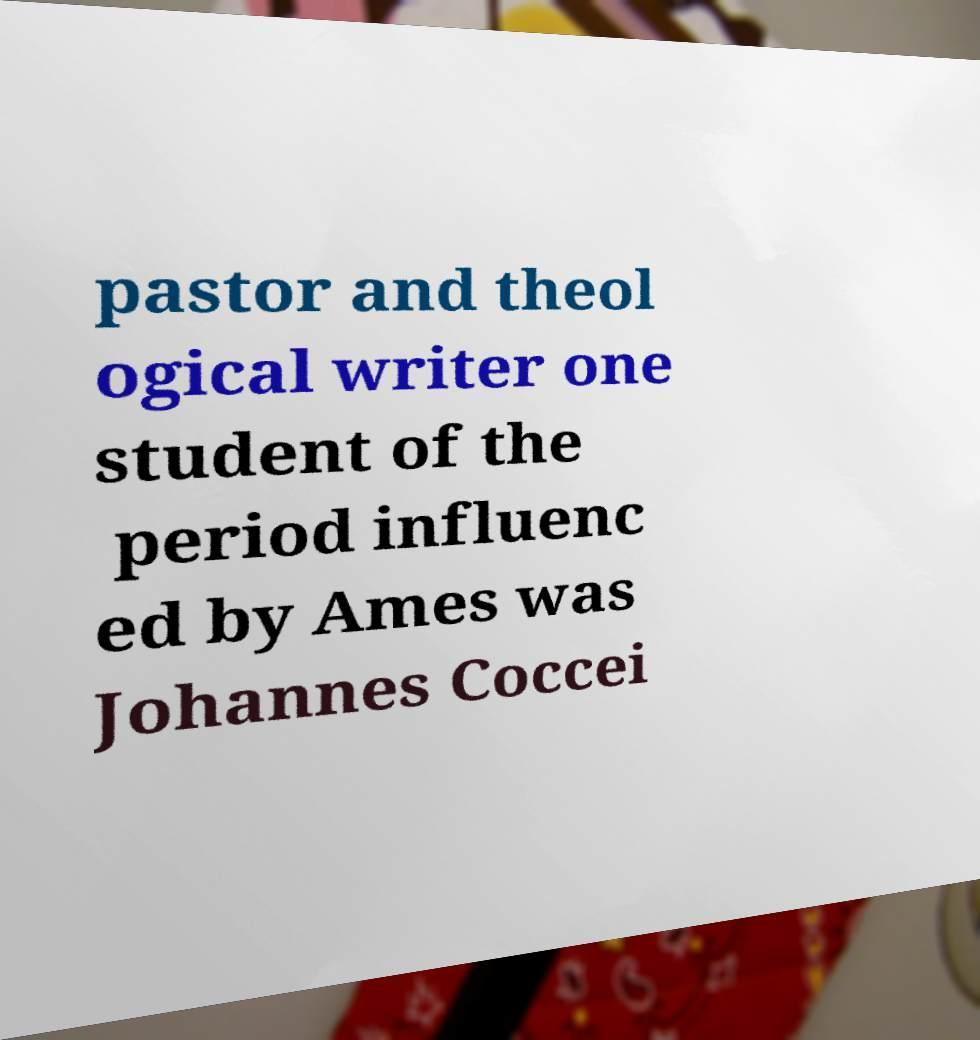I need the written content from this picture converted into text. Can you do that? pastor and theol ogical writer one student of the period influenc ed by Ames was Johannes Coccei 